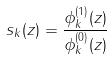Convert formula to latex. <formula><loc_0><loc_0><loc_500><loc_500>s _ { k } ( z ) = \frac { \phi _ { k } ^ { ( 1 ) } ( z ) } { \phi _ { k } ^ { ( 0 ) } ( z ) }</formula> 